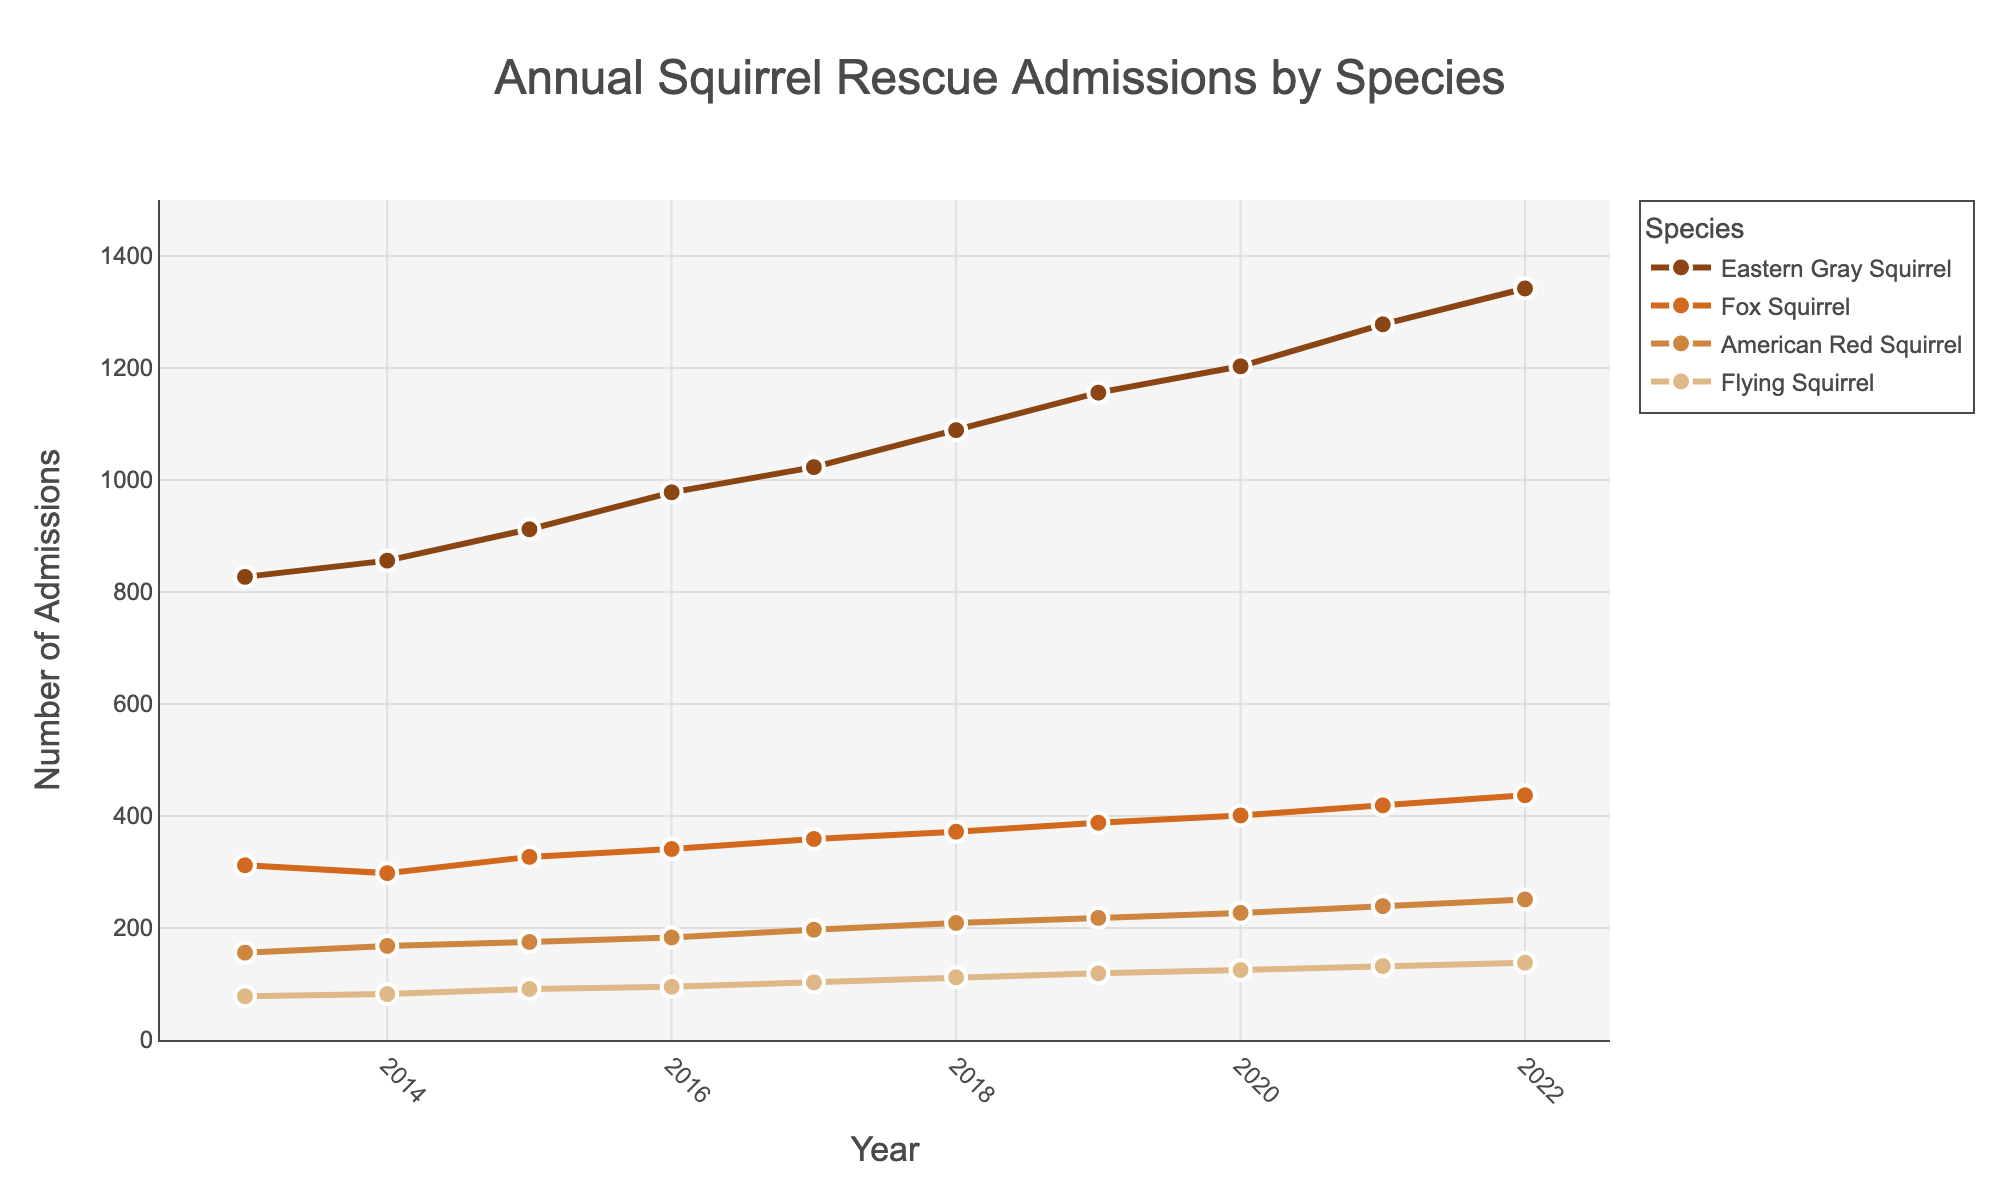Which species had the highest number of admissions in 2022? By observing the endpoint of the graph for the year 2022, we can identify the species with the highest admission. The species with the highest y-axis value in 2022 is the Eastern Gray Squirrel.
Answer: Eastern Gray Squirrel Which species showed the smallest increase in admissions from 2013 to 2022? To determine the smallest increase, compare the difference between the 2013 and 2022 values for each species. The differences are Eastern Gray Squirrel (1342-827), Fox Squirrel (437-312), American Red Squirrel (251-156), and Flying Squirrel (138-78). The smallest increase is for the Flying Squirrel.
Answer: Flying Squirrel By how much did the admissions for the Fox Squirrel increase between 2016 and 2020? Subtract the 2016 value from the 2020 value for the Fox Squirrel. The values are 401 (2020) and 341 (2016), so the increase is 401 - 341 = 60.
Answer: 60 What is the average number of admissions for the American Red Squirrel over the decade? Sum the number of admissions for each year and then divide by the number of years. (156 + 168 + 175 + 183 + 197 + 209 + 218 + 227 + 239 + 251) / 10 = 202.3
Answer: 202.3 Did any species experience a decrease in admissions during any year within the given time range? By examining the trend lines visually for each species from year to year, we can see that no species experienced a decrease in admissions at any point. All trends are upward.
Answer: No Which year saw the highest combined total admissions for all species? Add the number of admissions for all species for each year and compare. The highest combined total is in 2022. (1342 + 437 + 251 + 138 = 2168)
Answer: 2022 Between 2017 and 2018, which species had the largest percent increase in admissions? Calculate the percent increase for each species. Percent change = ((value in 2018 - value in 2017) / value in 2017) * 100. The largest increase comes from the Flying Squirrel. ((112 - 103) / 103) * 100 ≈ 8.74%
Answer: Flying Squirrel 